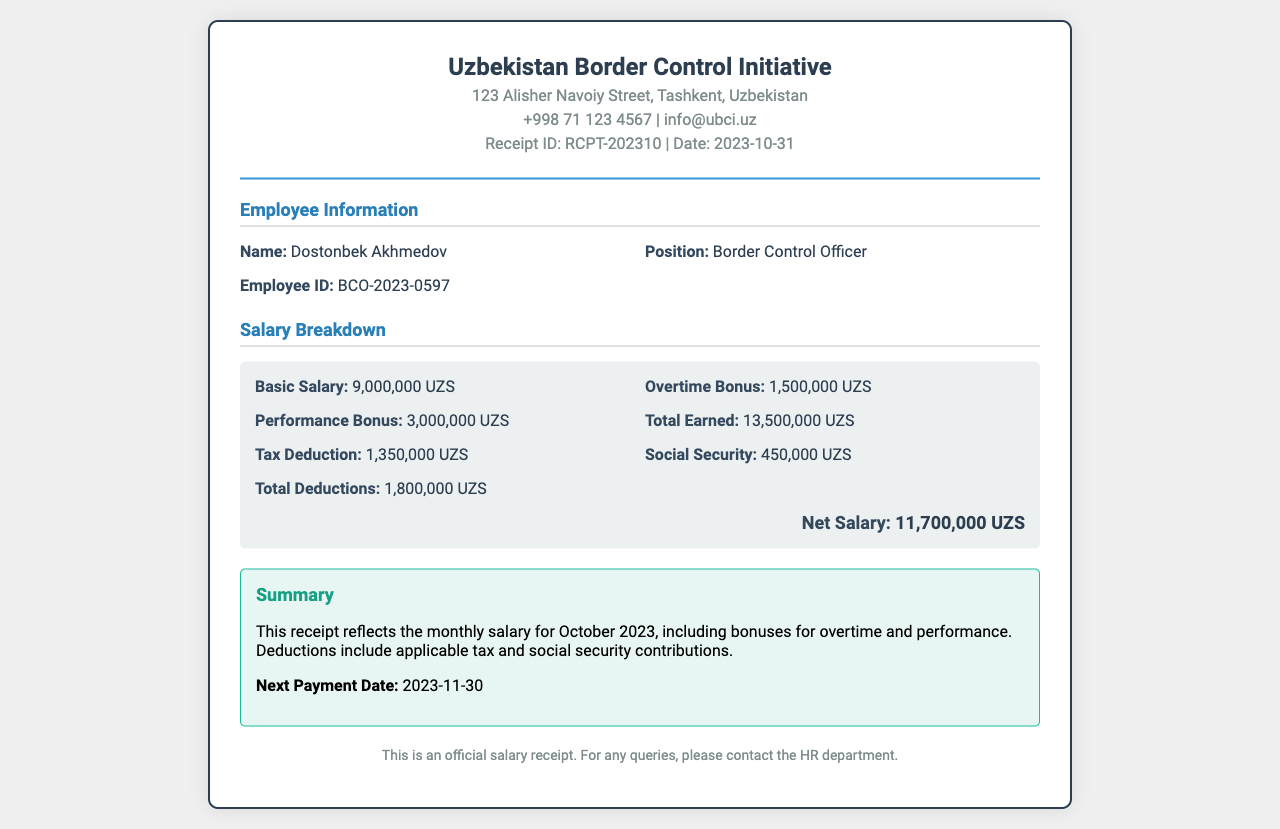What is the employee's name? The employee's name is clearly stated in the employee details section of the document.
Answer: Dostonbek Akhmedov What position does the employee hold? The position of the employee is listed under the employee details section.
Answer: Border Control Officer What is the employee ID? The employee ID is specified in the employee details section of the receipt.
Answer: BCO-2023-0597 What is the basic salary? The basic salary is detailed in the salary breakdown section.
Answer: 9,000,000 UZS What is the total earned before deductions? The total earned is calculated by summing all income sources listed in the salary breakdown.
Answer: 13,500,000 UZS What is the total deduction amount? The total deductions are clearly indicated in the salary breakdown section.
Answer: 1,800,000 UZS What is the net salary? The net salary is shown at the end of the salary breakdown, providing the final amount after deductions.
Answer: 11,700,000 UZS What date is this salary receipt for? The date of the receipt is mentioned prominently in the header section.
Answer: 2023-10-31 What is the next payment date? The next payment date is provided in the summary section of the receipt.
Answer: 2023-11-30 